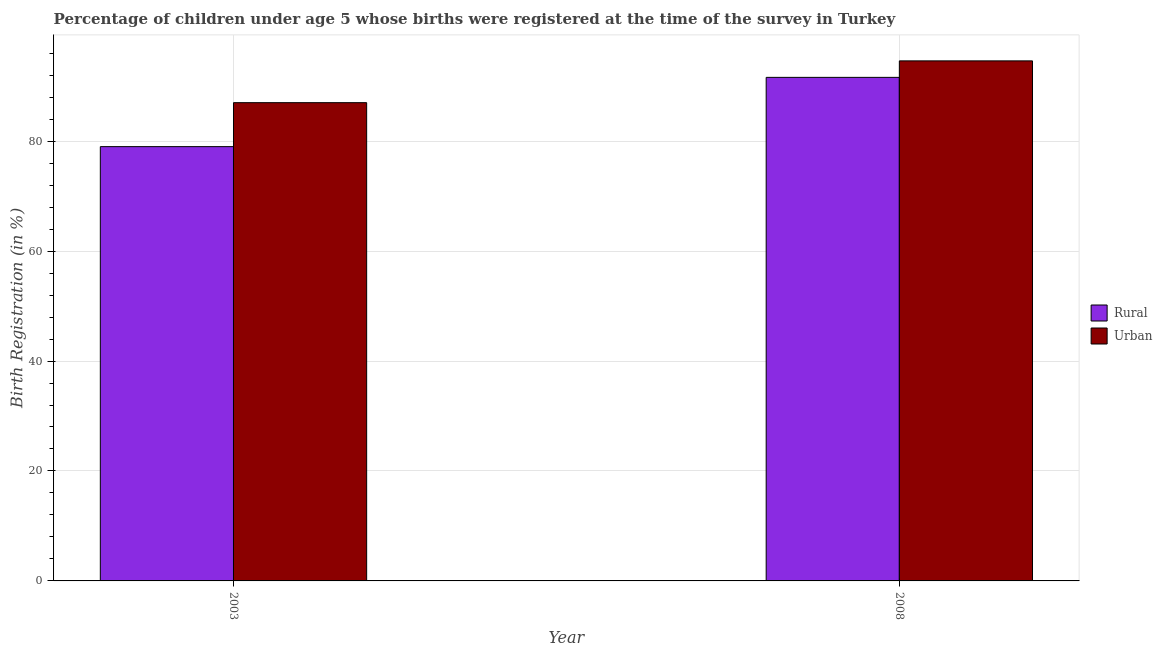How many different coloured bars are there?
Provide a short and direct response. 2. Are the number of bars per tick equal to the number of legend labels?
Your answer should be very brief. Yes. How many bars are there on the 2nd tick from the right?
Offer a terse response. 2. What is the label of the 1st group of bars from the left?
Give a very brief answer. 2003. In how many cases, is the number of bars for a given year not equal to the number of legend labels?
Your answer should be compact. 0. What is the rural birth registration in 2003?
Your answer should be compact. 79. Across all years, what is the maximum rural birth registration?
Ensure brevity in your answer.  91.6. Across all years, what is the minimum urban birth registration?
Keep it short and to the point. 87. What is the total rural birth registration in the graph?
Give a very brief answer. 170.6. What is the difference between the urban birth registration in 2003 and that in 2008?
Your answer should be very brief. -7.6. What is the difference between the urban birth registration in 2003 and the rural birth registration in 2008?
Provide a short and direct response. -7.6. What is the average rural birth registration per year?
Your answer should be compact. 85.3. In the year 2008, what is the difference between the rural birth registration and urban birth registration?
Offer a terse response. 0. What is the ratio of the urban birth registration in 2003 to that in 2008?
Make the answer very short. 0.92. What does the 2nd bar from the left in 2008 represents?
Your answer should be very brief. Urban. What does the 1st bar from the right in 2003 represents?
Keep it short and to the point. Urban. How many bars are there?
Offer a terse response. 4. Are all the bars in the graph horizontal?
Provide a short and direct response. No. How many years are there in the graph?
Your answer should be compact. 2. What is the difference between two consecutive major ticks on the Y-axis?
Offer a very short reply. 20. Are the values on the major ticks of Y-axis written in scientific E-notation?
Give a very brief answer. No. Does the graph contain any zero values?
Your answer should be very brief. No. Does the graph contain grids?
Give a very brief answer. Yes. Where does the legend appear in the graph?
Your answer should be very brief. Center right. What is the title of the graph?
Your answer should be very brief. Percentage of children under age 5 whose births were registered at the time of the survey in Turkey. What is the label or title of the Y-axis?
Give a very brief answer. Birth Registration (in %). What is the Birth Registration (in %) of Rural in 2003?
Provide a succinct answer. 79. What is the Birth Registration (in %) of Urban in 2003?
Offer a very short reply. 87. What is the Birth Registration (in %) of Rural in 2008?
Provide a short and direct response. 91.6. What is the Birth Registration (in %) of Urban in 2008?
Offer a very short reply. 94.6. Across all years, what is the maximum Birth Registration (in %) in Rural?
Keep it short and to the point. 91.6. Across all years, what is the maximum Birth Registration (in %) of Urban?
Make the answer very short. 94.6. Across all years, what is the minimum Birth Registration (in %) in Rural?
Offer a very short reply. 79. What is the total Birth Registration (in %) in Rural in the graph?
Keep it short and to the point. 170.6. What is the total Birth Registration (in %) in Urban in the graph?
Your answer should be very brief. 181.6. What is the difference between the Birth Registration (in %) in Urban in 2003 and that in 2008?
Keep it short and to the point. -7.6. What is the difference between the Birth Registration (in %) of Rural in 2003 and the Birth Registration (in %) of Urban in 2008?
Provide a short and direct response. -15.6. What is the average Birth Registration (in %) of Rural per year?
Provide a succinct answer. 85.3. What is the average Birth Registration (in %) in Urban per year?
Your answer should be compact. 90.8. What is the ratio of the Birth Registration (in %) of Rural in 2003 to that in 2008?
Provide a succinct answer. 0.86. What is the ratio of the Birth Registration (in %) of Urban in 2003 to that in 2008?
Your answer should be compact. 0.92. What is the difference between the highest and the second highest Birth Registration (in %) in Rural?
Ensure brevity in your answer.  12.6. 